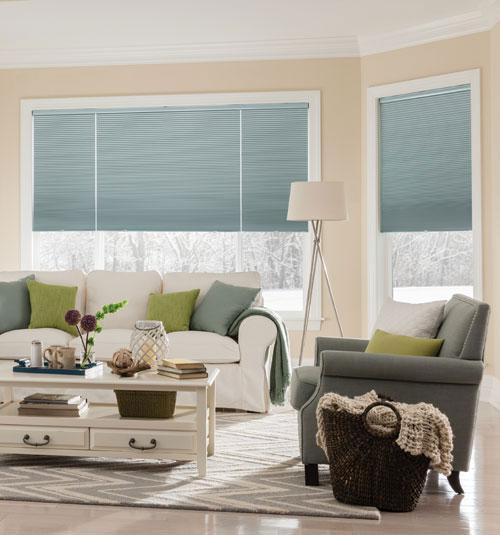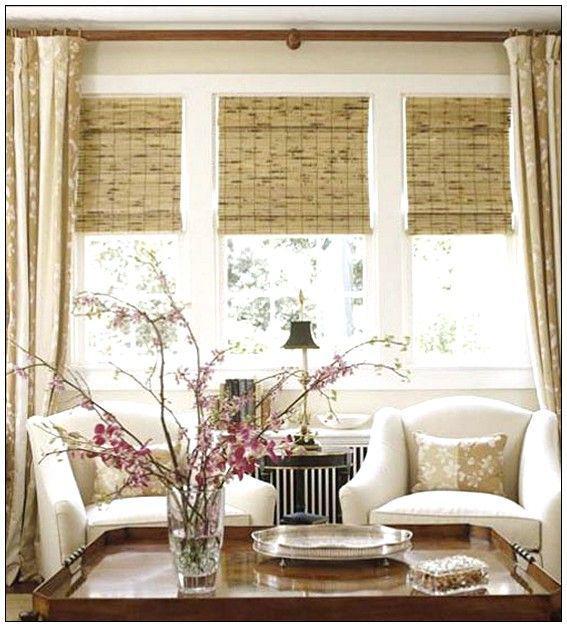The first image is the image on the left, the second image is the image on the right. Examine the images to the left and right. Is the description "There are no more than three blinds." accurate? Answer yes or no. No. The first image is the image on the left, the second image is the image on the right. Evaluate the accuracy of this statement regarding the images: "There are exactly two window shades in the left image.". Is it true? Answer yes or no. Yes. 